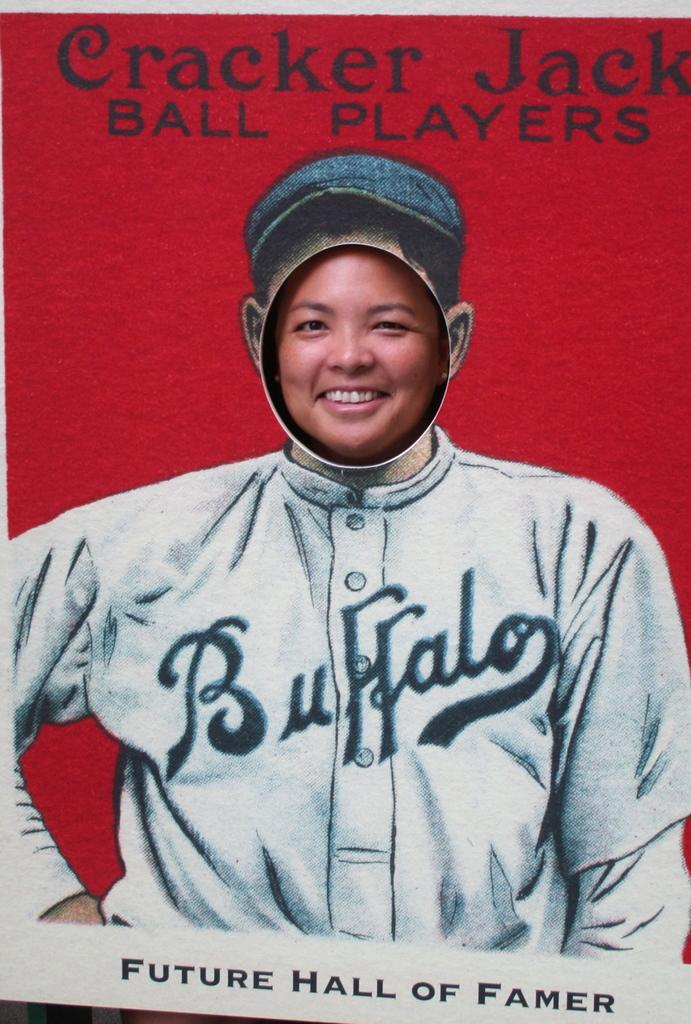<image>
Give a short and clear explanation of the subsequent image. A poster showing a picture of a baseball player with Future Hall of Famer underneath him. 